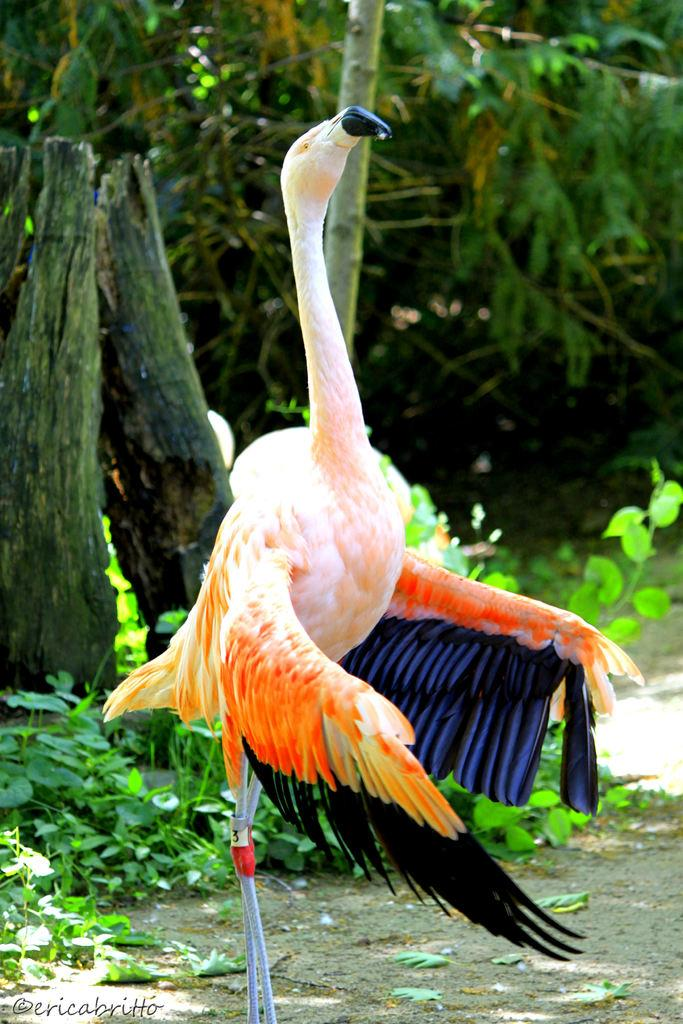What is located at the bottom of the image? There is a bird at the bottom of the image. What can be seen in the background of the image? There are trees and plants in the background of the image. What type of cup can be seen on the coast in the image? There is no cup or coast present in the image; it features a bird and trees/plants in the background. What kind of toys are visible with the bird in the image? There are no toys present in the image; it only features a bird and trees/plants in the background. 